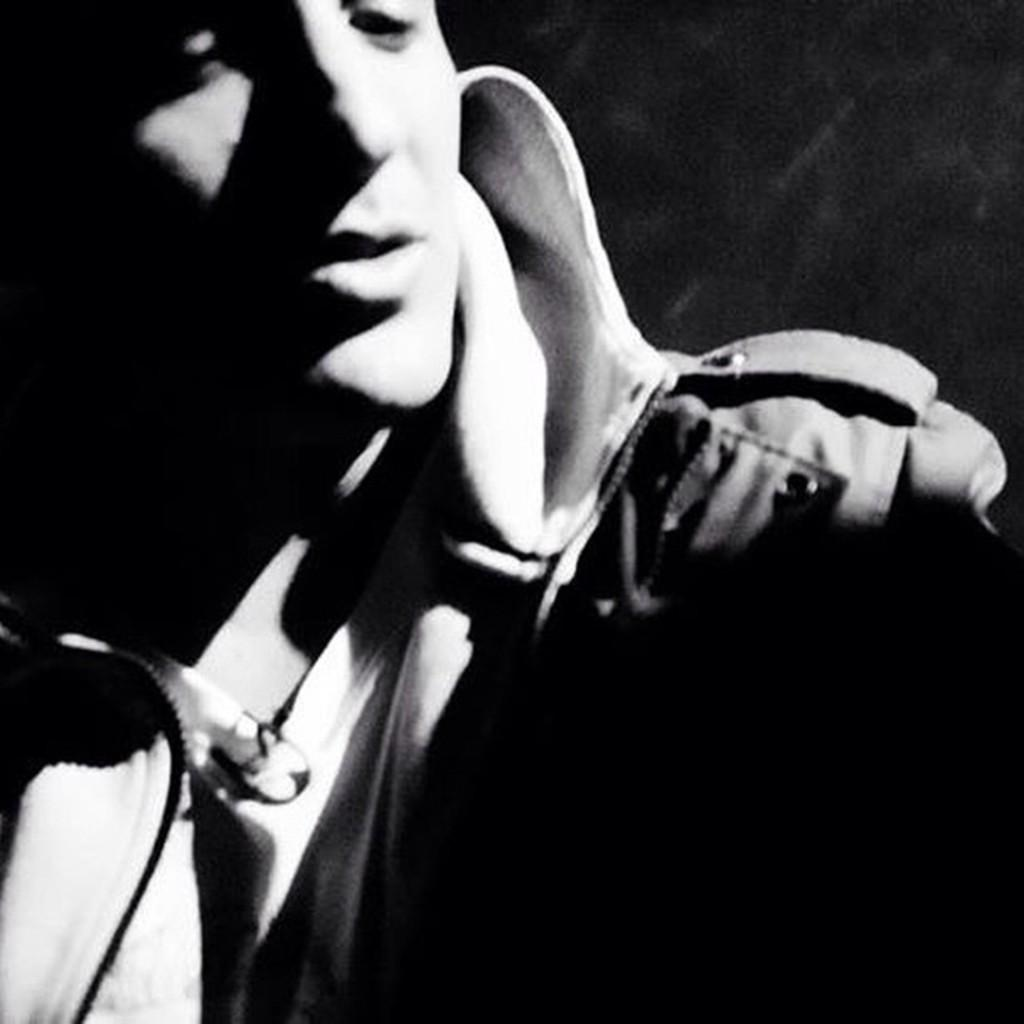What is the color scheme of the image? The image is black and white. Can you describe the main subject in the image? There is a person in the image. What can be observed about the background of the image? The background of the image is dark. What type of machine is being used by the person in the image? There is no machine visible in the image; it only features a person in a black and white setting with a dark background. What kind of quill is the person holding in the image? There is no quill present in the image. 